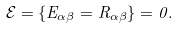Convert formula to latex. <formula><loc_0><loc_0><loc_500><loc_500>\mathcal { E } = \{ E _ { \alpha \beta } = R _ { \alpha \beta } \} = 0 .</formula> 